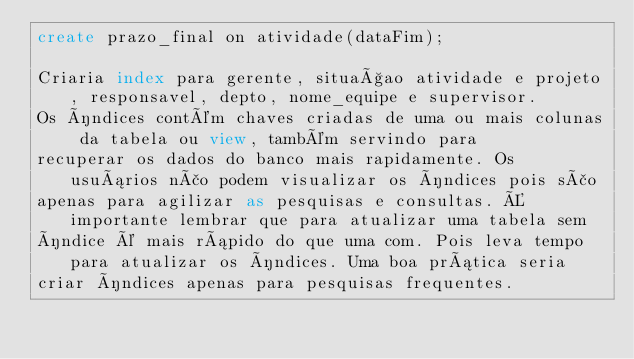Convert code to text. <code><loc_0><loc_0><loc_500><loc_500><_SQL_>create prazo_final on atividade(dataFim); 

Criaria index para gerente, situaçao atividade e projeto, responsavel, depto, nome_equipe e supervisor.
Os índices contém chaves criadas de uma ou mais colunas da tabela ou view, também servindo para
recuperar os dados do banco mais rapidamente. Os usuários não podem visualizar os índices pois são
apenas para agilizar as pesquisas e consultas. É importante lembrar que para atualizar uma tabela sem
índice é mais rápido do que uma com. Pois leva tempo para atualizar os índices. Uma boa prática seria
criar índices apenas para pesquisas frequentes.
</code> 